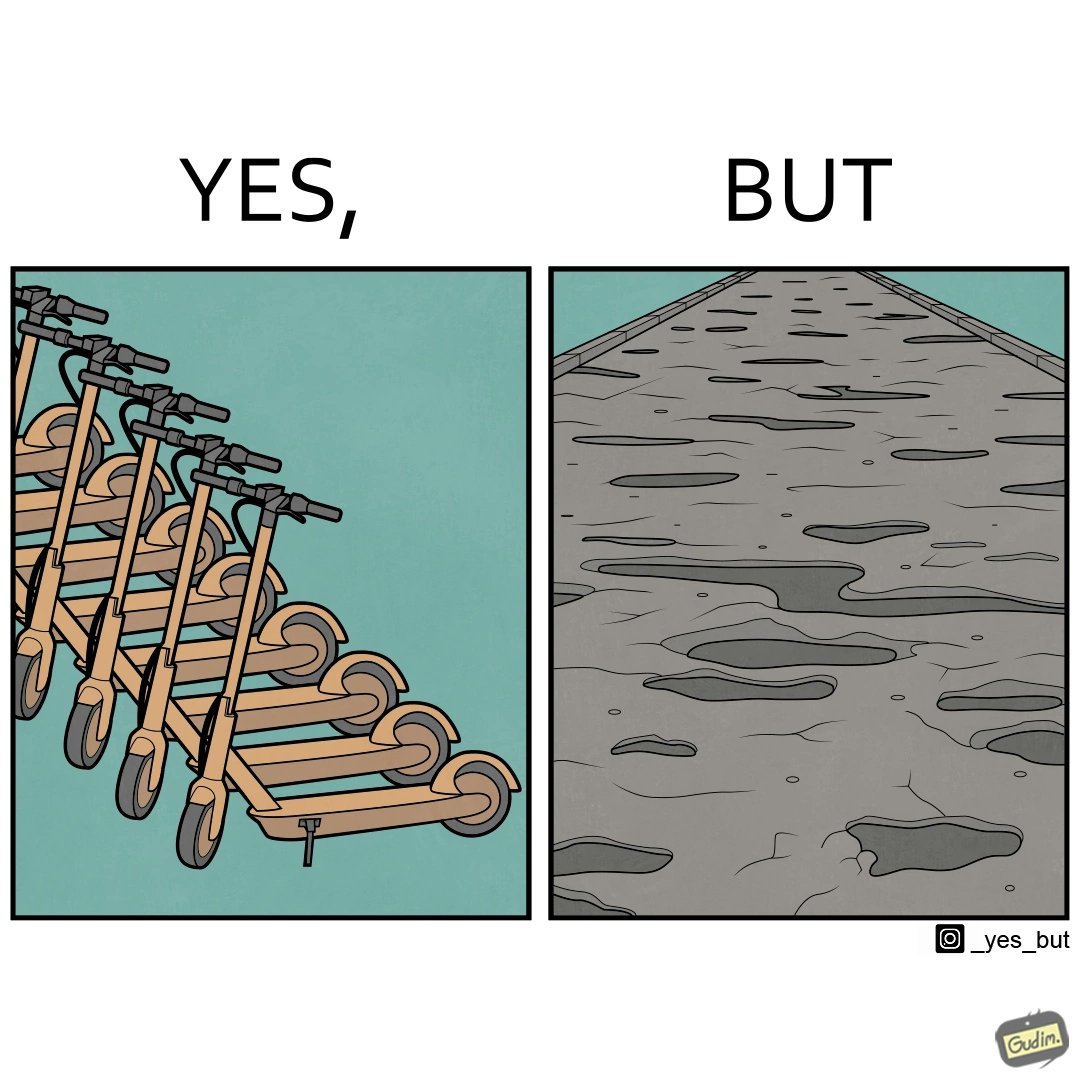Is this a satirical image? Yes, this image is satirical. 